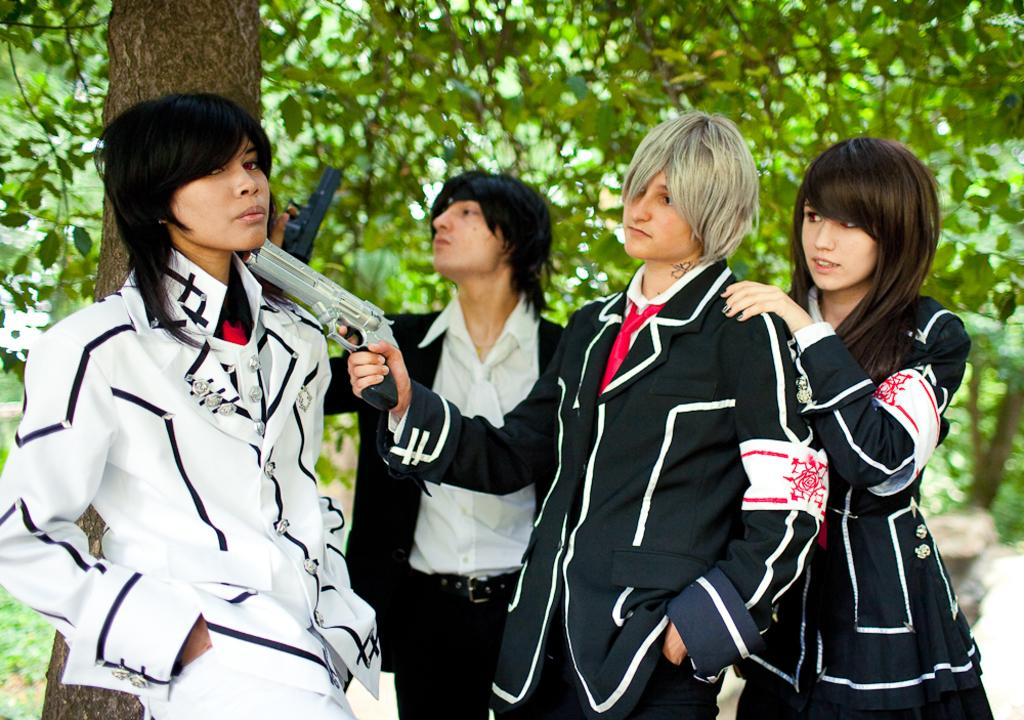What is happening in the middle of the image? There are people standing in the middle of the image. What are the people holding in their hands? The people are holding guns. What can be seen in the background of the image? There are trees visible in the background of the image. What type of brush is being used to paint the plastic scale in the image? There is no brush, plastic, or scale present in the image. 